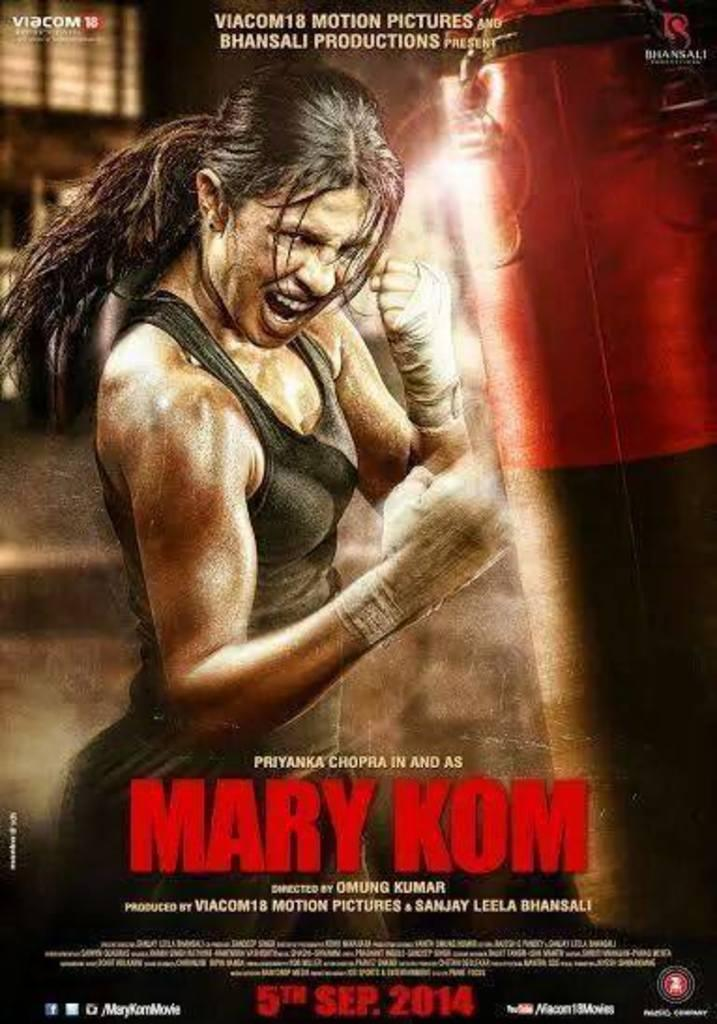<image>
Summarize the visual content of the image. The movie Mary Kom will come out in theatres on September 5, 2014. 